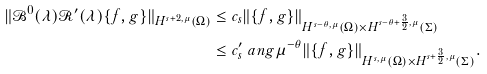Convert formula to latex. <formula><loc_0><loc_0><loc_500><loc_500>\| \mathcal { B } ^ { 0 } ( \lambda ) \mathcal { R } ^ { \prime } ( \lambda ) \{ f , g \} \| _ { H ^ { s + 2 , \mu } ( \Omega ) } & \leq c _ { s } \| \{ f , g \} \| _ { H ^ { s - \theta , \mu } ( \Omega ) \times { H } ^ { s - \theta + \frac { 3 } { 2 } , \mu } ( \Sigma ) } \\ & \leq c ^ { \prime } _ { s } \ a n g \mu ^ { - \theta } \| \{ f , g \} \| _ { H ^ { s , \mu } ( \Omega ) \times { H } ^ { s + \frac { 3 } { 2 } , \mu } ( \Sigma ) } .</formula> 